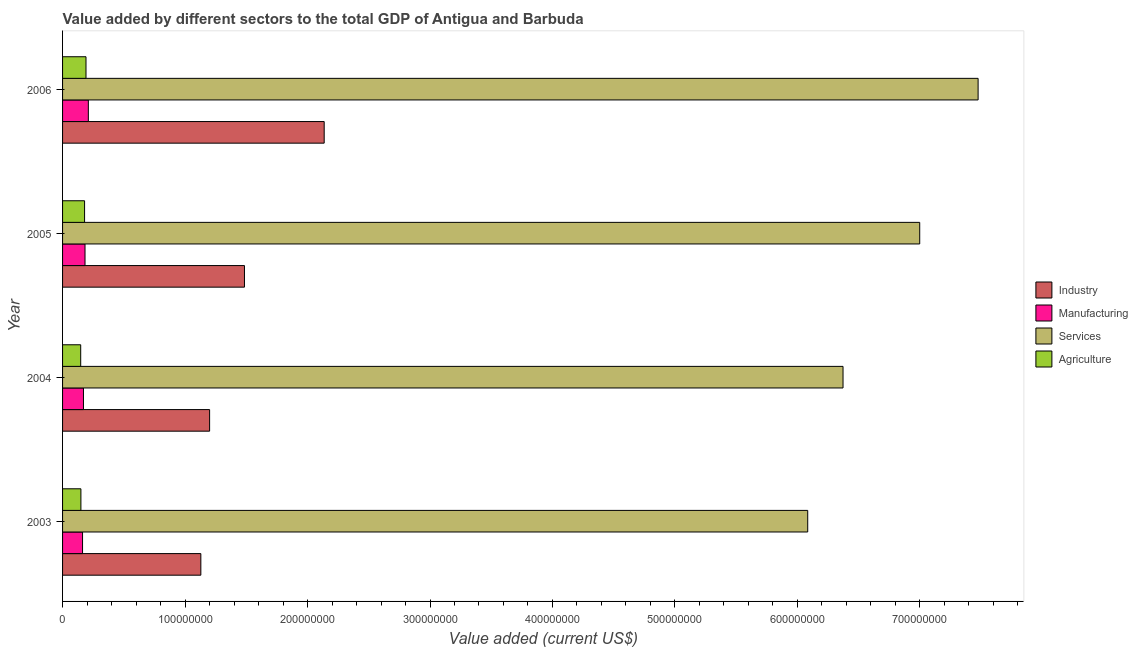How many groups of bars are there?
Keep it short and to the point. 4. How many bars are there on the 4th tick from the top?
Your answer should be very brief. 4. How many bars are there on the 4th tick from the bottom?
Provide a succinct answer. 4. What is the label of the 2nd group of bars from the top?
Provide a short and direct response. 2005. What is the value added by manufacturing sector in 2003?
Provide a succinct answer. 1.63e+07. Across all years, what is the maximum value added by agricultural sector?
Ensure brevity in your answer.  1.91e+07. Across all years, what is the minimum value added by agricultural sector?
Provide a short and direct response. 1.48e+07. What is the total value added by agricultural sector in the graph?
Your response must be concise. 6.69e+07. What is the difference between the value added by manufacturing sector in 2003 and that in 2005?
Make the answer very short. -2.02e+06. What is the difference between the value added by industrial sector in 2004 and the value added by services sector in 2005?
Provide a short and direct response. -5.80e+08. What is the average value added by manufacturing sector per year?
Offer a very short reply. 1.82e+07. In the year 2006, what is the difference between the value added by industrial sector and value added by services sector?
Make the answer very short. -5.34e+08. What is the ratio of the value added by industrial sector in 2003 to that in 2005?
Provide a short and direct response. 0.76. Is the difference between the value added by agricultural sector in 2004 and 2006 greater than the difference between the value added by manufacturing sector in 2004 and 2006?
Your answer should be compact. No. What is the difference between the highest and the second highest value added by agricultural sector?
Offer a very short reply. 1.16e+06. What is the difference between the highest and the lowest value added by agricultural sector?
Your response must be concise. 4.32e+06. In how many years, is the value added by industrial sector greater than the average value added by industrial sector taken over all years?
Keep it short and to the point. 1. Is it the case that in every year, the sum of the value added by industrial sector and value added by manufacturing sector is greater than the sum of value added by agricultural sector and value added by services sector?
Your answer should be compact. Yes. What does the 2nd bar from the top in 2004 represents?
Provide a short and direct response. Services. What does the 3rd bar from the bottom in 2005 represents?
Ensure brevity in your answer.  Services. Is it the case that in every year, the sum of the value added by industrial sector and value added by manufacturing sector is greater than the value added by services sector?
Offer a terse response. No. How many legend labels are there?
Provide a short and direct response. 4. How are the legend labels stacked?
Ensure brevity in your answer.  Vertical. What is the title of the graph?
Offer a very short reply. Value added by different sectors to the total GDP of Antigua and Barbuda. Does "Mammal species" appear as one of the legend labels in the graph?
Ensure brevity in your answer.  No. What is the label or title of the X-axis?
Your response must be concise. Value added (current US$). What is the label or title of the Y-axis?
Keep it short and to the point. Year. What is the Value added (current US$) of Industry in 2003?
Keep it short and to the point. 1.13e+08. What is the Value added (current US$) in Manufacturing in 2003?
Offer a very short reply. 1.63e+07. What is the Value added (current US$) in Services in 2003?
Your answer should be very brief. 6.08e+08. What is the Value added (current US$) in Agriculture in 2003?
Offer a very short reply. 1.50e+07. What is the Value added (current US$) of Industry in 2004?
Ensure brevity in your answer.  1.20e+08. What is the Value added (current US$) of Manufacturing in 2004?
Offer a terse response. 1.71e+07. What is the Value added (current US$) of Services in 2004?
Ensure brevity in your answer.  6.37e+08. What is the Value added (current US$) of Agriculture in 2004?
Offer a very short reply. 1.48e+07. What is the Value added (current US$) in Industry in 2005?
Ensure brevity in your answer.  1.49e+08. What is the Value added (current US$) in Manufacturing in 2005?
Give a very brief answer. 1.83e+07. What is the Value added (current US$) in Services in 2005?
Your answer should be compact. 7.00e+08. What is the Value added (current US$) in Agriculture in 2005?
Your answer should be compact. 1.80e+07. What is the Value added (current US$) in Industry in 2006?
Your response must be concise. 2.14e+08. What is the Value added (current US$) in Manufacturing in 2006?
Provide a succinct answer. 2.10e+07. What is the Value added (current US$) in Services in 2006?
Ensure brevity in your answer.  7.48e+08. What is the Value added (current US$) of Agriculture in 2006?
Make the answer very short. 1.91e+07. Across all years, what is the maximum Value added (current US$) in Industry?
Keep it short and to the point. 2.14e+08. Across all years, what is the maximum Value added (current US$) of Manufacturing?
Make the answer very short. 2.10e+07. Across all years, what is the maximum Value added (current US$) of Services?
Your response must be concise. 7.48e+08. Across all years, what is the maximum Value added (current US$) in Agriculture?
Provide a short and direct response. 1.91e+07. Across all years, what is the minimum Value added (current US$) of Industry?
Your response must be concise. 1.13e+08. Across all years, what is the minimum Value added (current US$) in Manufacturing?
Your answer should be compact. 1.63e+07. Across all years, what is the minimum Value added (current US$) in Services?
Keep it short and to the point. 6.08e+08. Across all years, what is the minimum Value added (current US$) in Agriculture?
Provide a succinct answer. 1.48e+07. What is the total Value added (current US$) of Industry in the graph?
Offer a very short reply. 5.95e+08. What is the total Value added (current US$) of Manufacturing in the graph?
Provide a short and direct response. 7.27e+07. What is the total Value added (current US$) of Services in the graph?
Keep it short and to the point. 2.69e+09. What is the total Value added (current US$) in Agriculture in the graph?
Give a very brief answer. 6.69e+07. What is the difference between the Value added (current US$) in Industry in 2003 and that in 2004?
Your response must be concise. -7.15e+06. What is the difference between the Value added (current US$) of Manufacturing in 2003 and that in 2004?
Offer a very short reply. -7.57e+05. What is the difference between the Value added (current US$) in Services in 2003 and that in 2004?
Offer a terse response. -2.88e+07. What is the difference between the Value added (current US$) of Agriculture in 2003 and that in 2004?
Your answer should be compact. 1.65e+05. What is the difference between the Value added (current US$) in Industry in 2003 and that in 2005?
Offer a terse response. -3.56e+07. What is the difference between the Value added (current US$) of Manufacturing in 2003 and that in 2005?
Provide a succinct answer. -2.02e+06. What is the difference between the Value added (current US$) in Services in 2003 and that in 2005?
Your response must be concise. -9.14e+07. What is the difference between the Value added (current US$) of Agriculture in 2003 and that in 2005?
Your answer should be compact. -3.00e+06. What is the difference between the Value added (current US$) of Industry in 2003 and that in 2006?
Provide a short and direct response. -1.01e+08. What is the difference between the Value added (current US$) of Manufacturing in 2003 and that in 2006?
Ensure brevity in your answer.  -4.73e+06. What is the difference between the Value added (current US$) of Services in 2003 and that in 2006?
Keep it short and to the point. -1.39e+08. What is the difference between the Value added (current US$) of Agriculture in 2003 and that in 2006?
Offer a terse response. -4.16e+06. What is the difference between the Value added (current US$) of Industry in 2004 and that in 2005?
Provide a short and direct response. -2.85e+07. What is the difference between the Value added (current US$) in Manufacturing in 2004 and that in 2005?
Offer a terse response. -1.26e+06. What is the difference between the Value added (current US$) of Services in 2004 and that in 2005?
Offer a very short reply. -6.26e+07. What is the difference between the Value added (current US$) of Agriculture in 2004 and that in 2005?
Give a very brief answer. -3.16e+06. What is the difference between the Value added (current US$) of Industry in 2004 and that in 2006?
Your response must be concise. -9.36e+07. What is the difference between the Value added (current US$) in Manufacturing in 2004 and that in 2006?
Make the answer very short. -3.98e+06. What is the difference between the Value added (current US$) in Services in 2004 and that in 2006?
Provide a short and direct response. -1.10e+08. What is the difference between the Value added (current US$) of Agriculture in 2004 and that in 2006?
Ensure brevity in your answer.  -4.32e+06. What is the difference between the Value added (current US$) in Industry in 2005 and that in 2006?
Ensure brevity in your answer.  -6.51e+07. What is the difference between the Value added (current US$) in Manufacturing in 2005 and that in 2006?
Offer a very short reply. -2.72e+06. What is the difference between the Value added (current US$) of Services in 2005 and that in 2006?
Provide a short and direct response. -4.77e+07. What is the difference between the Value added (current US$) in Agriculture in 2005 and that in 2006?
Provide a succinct answer. -1.16e+06. What is the difference between the Value added (current US$) of Industry in 2003 and the Value added (current US$) of Manufacturing in 2004?
Your response must be concise. 9.58e+07. What is the difference between the Value added (current US$) in Industry in 2003 and the Value added (current US$) in Services in 2004?
Your response must be concise. -5.24e+08. What is the difference between the Value added (current US$) of Industry in 2003 and the Value added (current US$) of Agriculture in 2004?
Your answer should be compact. 9.81e+07. What is the difference between the Value added (current US$) in Manufacturing in 2003 and the Value added (current US$) in Services in 2004?
Your response must be concise. -6.21e+08. What is the difference between the Value added (current US$) in Manufacturing in 2003 and the Value added (current US$) in Agriculture in 2004?
Ensure brevity in your answer.  1.50e+06. What is the difference between the Value added (current US$) of Services in 2003 and the Value added (current US$) of Agriculture in 2004?
Provide a succinct answer. 5.94e+08. What is the difference between the Value added (current US$) of Industry in 2003 and the Value added (current US$) of Manufacturing in 2005?
Keep it short and to the point. 9.46e+07. What is the difference between the Value added (current US$) of Industry in 2003 and the Value added (current US$) of Services in 2005?
Provide a short and direct response. -5.87e+08. What is the difference between the Value added (current US$) in Industry in 2003 and the Value added (current US$) in Agriculture in 2005?
Your answer should be compact. 9.49e+07. What is the difference between the Value added (current US$) in Manufacturing in 2003 and the Value added (current US$) in Services in 2005?
Your answer should be very brief. -6.84e+08. What is the difference between the Value added (current US$) of Manufacturing in 2003 and the Value added (current US$) of Agriculture in 2005?
Provide a succinct answer. -1.66e+06. What is the difference between the Value added (current US$) in Services in 2003 and the Value added (current US$) in Agriculture in 2005?
Give a very brief answer. 5.90e+08. What is the difference between the Value added (current US$) in Industry in 2003 and the Value added (current US$) in Manufacturing in 2006?
Ensure brevity in your answer.  9.19e+07. What is the difference between the Value added (current US$) in Industry in 2003 and the Value added (current US$) in Services in 2006?
Your answer should be compact. -6.35e+08. What is the difference between the Value added (current US$) in Industry in 2003 and the Value added (current US$) in Agriculture in 2006?
Your response must be concise. 9.38e+07. What is the difference between the Value added (current US$) of Manufacturing in 2003 and the Value added (current US$) of Services in 2006?
Keep it short and to the point. -7.31e+08. What is the difference between the Value added (current US$) in Manufacturing in 2003 and the Value added (current US$) in Agriculture in 2006?
Make the answer very short. -2.82e+06. What is the difference between the Value added (current US$) in Services in 2003 and the Value added (current US$) in Agriculture in 2006?
Offer a very short reply. 5.89e+08. What is the difference between the Value added (current US$) of Industry in 2004 and the Value added (current US$) of Manufacturing in 2005?
Offer a terse response. 1.02e+08. What is the difference between the Value added (current US$) of Industry in 2004 and the Value added (current US$) of Services in 2005?
Provide a short and direct response. -5.80e+08. What is the difference between the Value added (current US$) in Industry in 2004 and the Value added (current US$) in Agriculture in 2005?
Offer a very short reply. 1.02e+08. What is the difference between the Value added (current US$) in Manufacturing in 2004 and the Value added (current US$) in Services in 2005?
Provide a succinct answer. -6.83e+08. What is the difference between the Value added (current US$) in Manufacturing in 2004 and the Value added (current US$) in Agriculture in 2005?
Offer a terse response. -9.02e+05. What is the difference between the Value added (current US$) in Services in 2004 and the Value added (current US$) in Agriculture in 2005?
Your answer should be compact. 6.19e+08. What is the difference between the Value added (current US$) of Industry in 2004 and the Value added (current US$) of Manufacturing in 2006?
Make the answer very short. 9.90e+07. What is the difference between the Value added (current US$) of Industry in 2004 and the Value added (current US$) of Services in 2006?
Give a very brief answer. -6.27e+08. What is the difference between the Value added (current US$) of Industry in 2004 and the Value added (current US$) of Agriculture in 2006?
Your answer should be compact. 1.01e+08. What is the difference between the Value added (current US$) of Manufacturing in 2004 and the Value added (current US$) of Services in 2006?
Provide a short and direct response. -7.30e+08. What is the difference between the Value added (current US$) of Manufacturing in 2004 and the Value added (current US$) of Agriculture in 2006?
Your response must be concise. -2.06e+06. What is the difference between the Value added (current US$) in Services in 2004 and the Value added (current US$) in Agriculture in 2006?
Make the answer very short. 6.18e+08. What is the difference between the Value added (current US$) of Industry in 2005 and the Value added (current US$) of Manufacturing in 2006?
Provide a succinct answer. 1.27e+08. What is the difference between the Value added (current US$) of Industry in 2005 and the Value added (current US$) of Services in 2006?
Your answer should be compact. -5.99e+08. What is the difference between the Value added (current US$) in Industry in 2005 and the Value added (current US$) in Agriculture in 2006?
Your response must be concise. 1.29e+08. What is the difference between the Value added (current US$) in Manufacturing in 2005 and the Value added (current US$) in Services in 2006?
Ensure brevity in your answer.  -7.29e+08. What is the difference between the Value added (current US$) of Manufacturing in 2005 and the Value added (current US$) of Agriculture in 2006?
Keep it short and to the point. -8.00e+05. What is the difference between the Value added (current US$) in Services in 2005 and the Value added (current US$) in Agriculture in 2006?
Provide a short and direct response. 6.81e+08. What is the average Value added (current US$) of Industry per year?
Give a very brief answer. 1.49e+08. What is the average Value added (current US$) in Manufacturing per year?
Provide a succinct answer. 1.82e+07. What is the average Value added (current US$) in Services per year?
Your response must be concise. 6.73e+08. What is the average Value added (current US$) of Agriculture per year?
Offer a very short reply. 1.67e+07. In the year 2003, what is the difference between the Value added (current US$) in Industry and Value added (current US$) in Manufacturing?
Provide a short and direct response. 9.66e+07. In the year 2003, what is the difference between the Value added (current US$) of Industry and Value added (current US$) of Services?
Keep it short and to the point. -4.96e+08. In the year 2003, what is the difference between the Value added (current US$) in Industry and Value added (current US$) in Agriculture?
Provide a short and direct response. 9.79e+07. In the year 2003, what is the difference between the Value added (current US$) in Manufacturing and Value added (current US$) in Services?
Your response must be concise. -5.92e+08. In the year 2003, what is the difference between the Value added (current US$) in Manufacturing and Value added (current US$) in Agriculture?
Provide a short and direct response. 1.34e+06. In the year 2003, what is the difference between the Value added (current US$) of Services and Value added (current US$) of Agriculture?
Ensure brevity in your answer.  5.93e+08. In the year 2004, what is the difference between the Value added (current US$) in Industry and Value added (current US$) in Manufacturing?
Your response must be concise. 1.03e+08. In the year 2004, what is the difference between the Value added (current US$) in Industry and Value added (current US$) in Services?
Offer a very short reply. -5.17e+08. In the year 2004, what is the difference between the Value added (current US$) of Industry and Value added (current US$) of Agriculture?
Give a very brief answer. 1.05e+08. In the year 2004, what is the difference between the Value added (current US$) of Manufacturing and Value added (current US$) of Services?
Keep it short and to the point. -6.20e+08. In the year 2004, what is the difference between the Value added (current US$) of Manufacturing and Value added (current US$) of Agriculture?
Give a very brief answer. 2.26e+06. In the year 2004, what is the difference between the Value added (current US$) in Services and Value added (current US$) in Agriculture?
Your response must be concise. 6.22e+08. In the year 2005, what is the difference between the Value added (current US$) in Industry and Value added (current US$) in Manufacturing?
Offer a terse response. 1.30e+08. In the year 2005, what is the difference between the Value added (current US$) of Industry and Value added (current US$) of Services?
Keep it short and to the point. -5.51e+08. In the year 2005, what is the difference between the Value added (current US$) of Industry and Value added (current US$) of Agriculture?
Provide a short and direct response. 1.31e+08. In the year 2005, what is the difference between the Value added (current US$) in Manufacturing and Value added (current US$) in Services?
Your answer should be very brief. -6.82e+08. In the year 2005, what is the difference between the Value added (current US$) in Manufacturing and Value added (current US$) in Agriculture?
Your answer should be very brief. 3.59e+05. In the year 2005, what is the difference between the Value added (current US$) in Services and Value added (current US$) in Agriculture?
Make the answer very short. 6.82e+08. In the year 2006, what is the difference between the Value added (current US$) of Industry and Value added (current US$) of Manufacturing?
Provide a succinct answer. 1.93e+08. In the year 2006, what is the difference between the Value added (current US$) in Industry and Value added (current US$) in Services?
Make the answer very short. -5.34e+08. In the year 2006, what is the difference between the Value added (current US$) of Industry and Value added (current US$) of Agriculture?
Make the answer very short. 1.94e+08. In the year 2006, what is the difference between the Value added (current US$) of Manufacturing and Value added (current US$) of Services?
Offer a terse response. -7.26e+08. In the year 2006, what is the difference between the Value added (current US$) of Manufacturing and Value added (current US$) of Agriculture?
Your answer should be compact. 1.92e+06. In the year 2006, what is the difference between the Value added (current US$) of Services and Value added (current US$) of Agriculture?
Keep it short and to the point. 7.28e+08. What is the ratio of the Value added (current US$) of Industry in 2003 to that in 2004?
Your response must be concise. 0.94. What is the ratio of the Value added (current US$) in Manufacturing in 2003 to that in 2004?
Your answer should be compact. 0.96. What is the ratio of the Value added (current US$) of Services in 2003 to that in 2004?
Keep it short and to the point. 0.95. What is the ratio of the Value added (current US$) of Agriculture in 2003 to that in 2004?
Ensure brevity in your answer.  1.01. What is the ratio of the Value added (current US$) in Industry in 2003 to that in 2005?
Provide a succinct answer. 0.76. What is the ratio of the Value added (current US$) in Manufacturing in 2003 to that in 2005?
Your response must be concise. 0.89. What is the ratio of the Value added (current US$) of Services in 2003 to that in 2005?
Ensure brevity in your answer.  0.87. What is the ratio of the Value added (current US$) of Agriculture in 2003 to that in 2005?
Provide a short and direct response. 0.83. What is the ratio of the Value added (current US$) of Industry in 2003 to that in 2006?
Offer a very short reply. 0.53. What is the ratio of the Value added (current US$) of Manufacturing in 2003 to that in 2006?
Your answer should be compact. 0.78. What is the ratio of the Value added (current US$) of Services in 2003 to that in 2006?
Ensure brevity in your answer.  0.81. What is the ratio of the Value added (current US$) in Agriculture in 2003 to that in 2006?
Your answer should be very brief. 0.78. What is the ratio of the Value added (current US$) of Industry in 2004 to that in 2005?
Provide a short and direct response. 0.81. What is the ratio of the Value added (current US$) in Manufacturing in 2004 to that in 2005?
Keep it short and to the point. 0.93. What is the ratio of the Value added (current US$) of Services in 2004 to that in 2005?
Offer a very short reply. 0.91. What is the ratio of the Value added (current US$) in Agriculture in 2004 to that in 2005?
Provide a short and direct response. 0.82. What is the ratio of the Value added (current US$) of Industry in 2004 to that in 2006?
Your response must be concise. 0.56. What is the ratio of the Value added (current US$) of Manufacturing in 2004 to that in 2006?
Make the answer very short. 0.81. What is the ratio of the Value added (current US$) in Services in 2004 to that in 2006?
Provide a short and direct response. 0.85. What is the ratio of the Value added (current US$) in Agriculture in 2004 to that in 2006?
Offer a terse response. 0.77. What is the ratio of the Value added (current US$) of Industry in 2005 to that in 2006?
Offer a terse response. 0.7. What is the ratio of the Value added (current US$) in Manufacturing in 2005 to that in 2006?
Ensure brevity in your answer.  0.87. What is the ratio of the Value added (current US$) in Services in 2005 to that in 2006?
Ensure brevity in your answer.  0.94. What is the ratio of the Value added (current US$) in Agriculture in 2005 to that in 2006?
Give a very brief answer. 0.94. What is the difference between the highest and the second highest Value added (current US$) of Industry?
Ensure brevity in your answer.  6.51e+07. What is the difference between the highest and the second highest Value added (current US$) in Manufacturing?
Provide a short and direct response. 2.72e+06. What is the difference between the highest and the second highest Value added (current US$) of Services?
Keep it short and to the point. 4.77e+07. What is the difference between the highest and the second highest Value added (current US$) in Agriculture?
Give a very brief answer. 1.16e+06. What is the difference between the highest and the lowest Value added (current US$) of Industry?
Your answer should be very brief. 1.01e+08. What is the difference between the highest and the lowest Value added (current US$) in Manufacturing?
Provide a succinct answer. 4.73e+06. What is the difference between the highest and the lowest Value added (current US$) in Services?
Make the answer very short. 1.39e+08. What is the difference between the highest and the lowest Value added (current US$) in Agriculture?
Ensure brevity in your answer.  4.32e+06. 